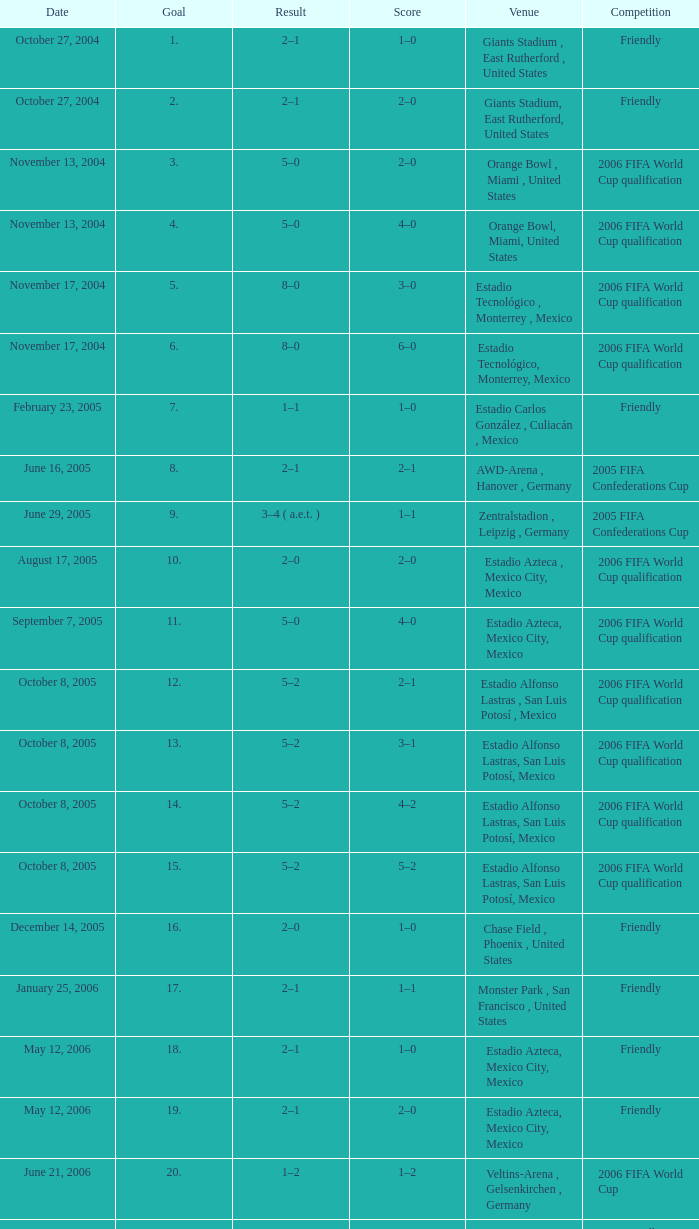Which Score has a Result of 2–1, and a Competition of friendly, and a Goal smaller than 17? 1–0, 2–0. 